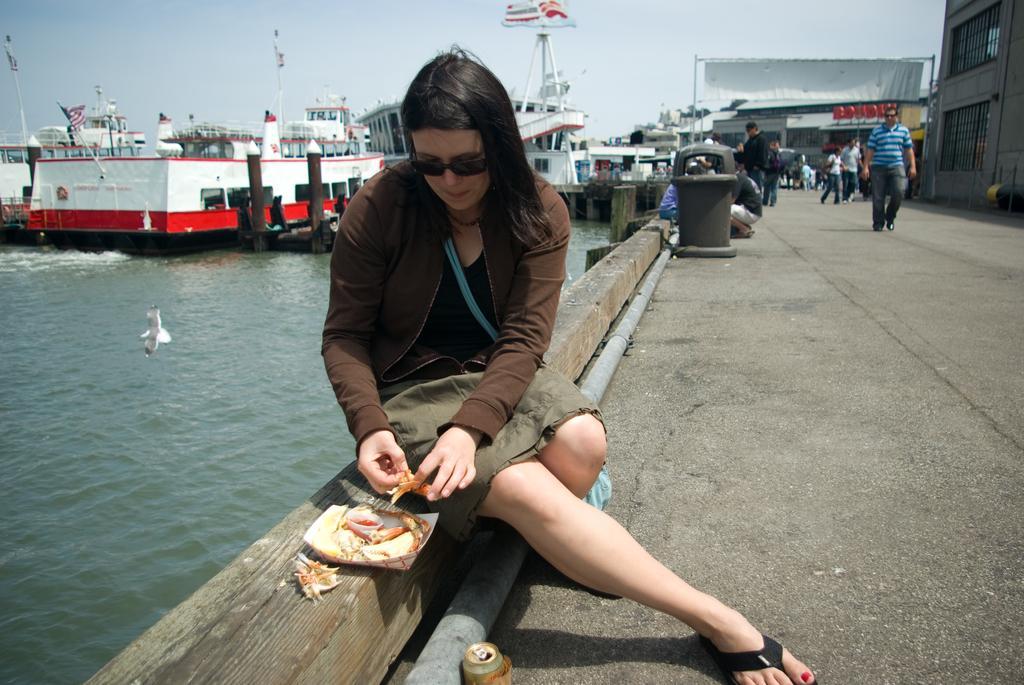How would you summarize this image in a sentence or two? In this image in the foreground there is one person who is sitting on a wooden pole, and in front of her there is one plate. In that plate there is some food items and she is holding a food item, in the background there is a river. In that river there are some boats and on the right side there is a bridge and on the bridge there are some people who are walking and some of them are standing, and also there is one dustbin in the center. In the background there are some houses and trees. 